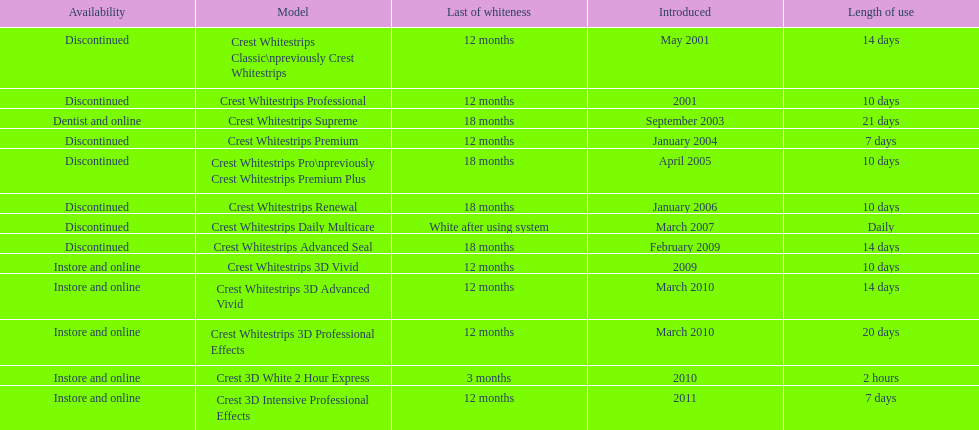What product was introduced in the same month as crest whitestrips 3d advanced vivid? Crest Whitestrips 3D Professional Effects. 